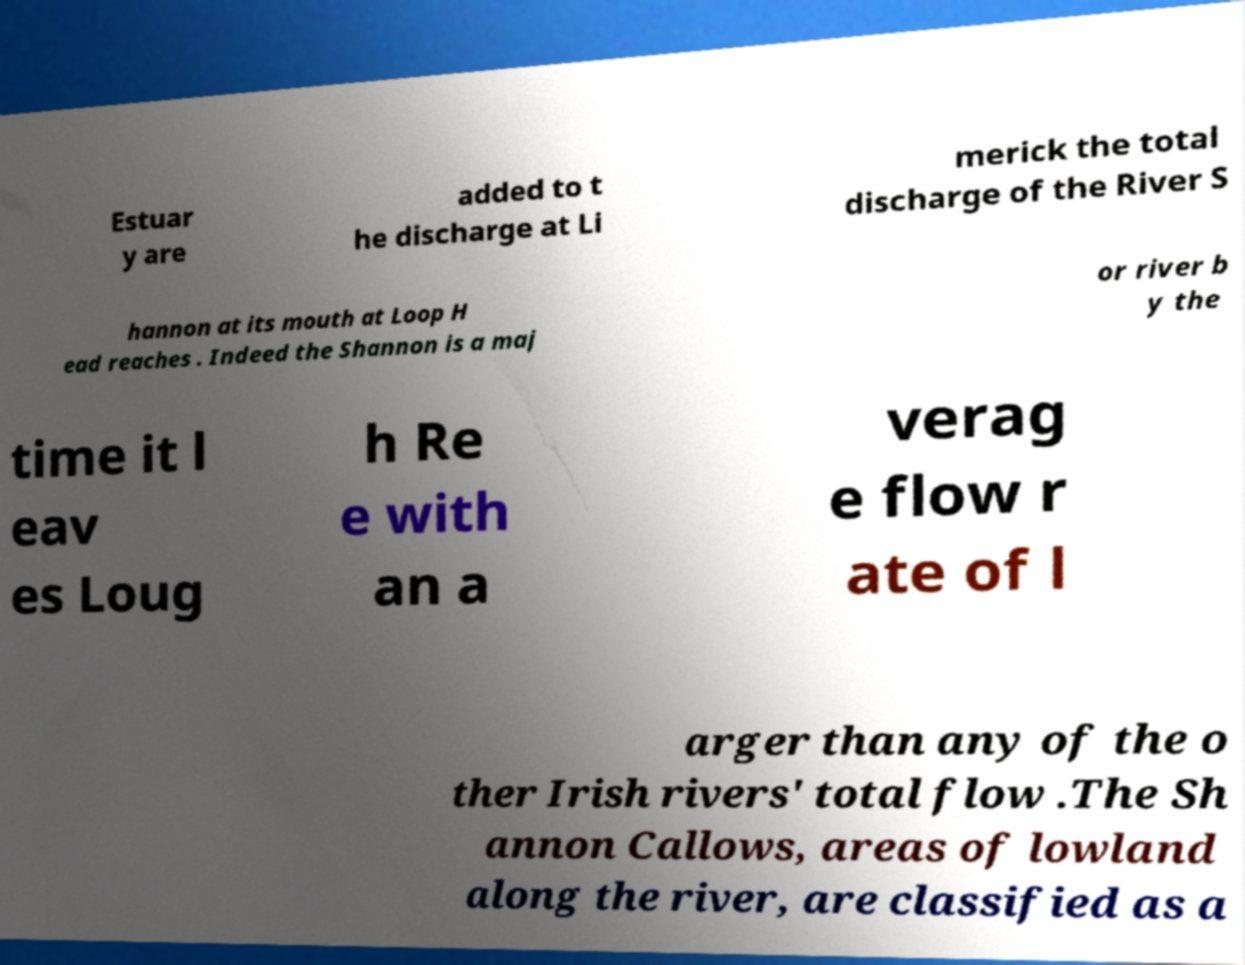Can you read and provide the text displayed in the image?This photo seems to have some interesting text. Can you extract and type it out for me? Estuar y are added to t he discharge at Li merick the total discharge of the River S hannon at its mouth at Loop H ead reaches . Indeed the Shannon is a maj or river b y the time it l eav es Loug h Re e with an a verag e flow r ate of l arger than any of the o ther Irish rivers' total flow .The Sh annon Callows, areas of lowland along the river, are classified as a 